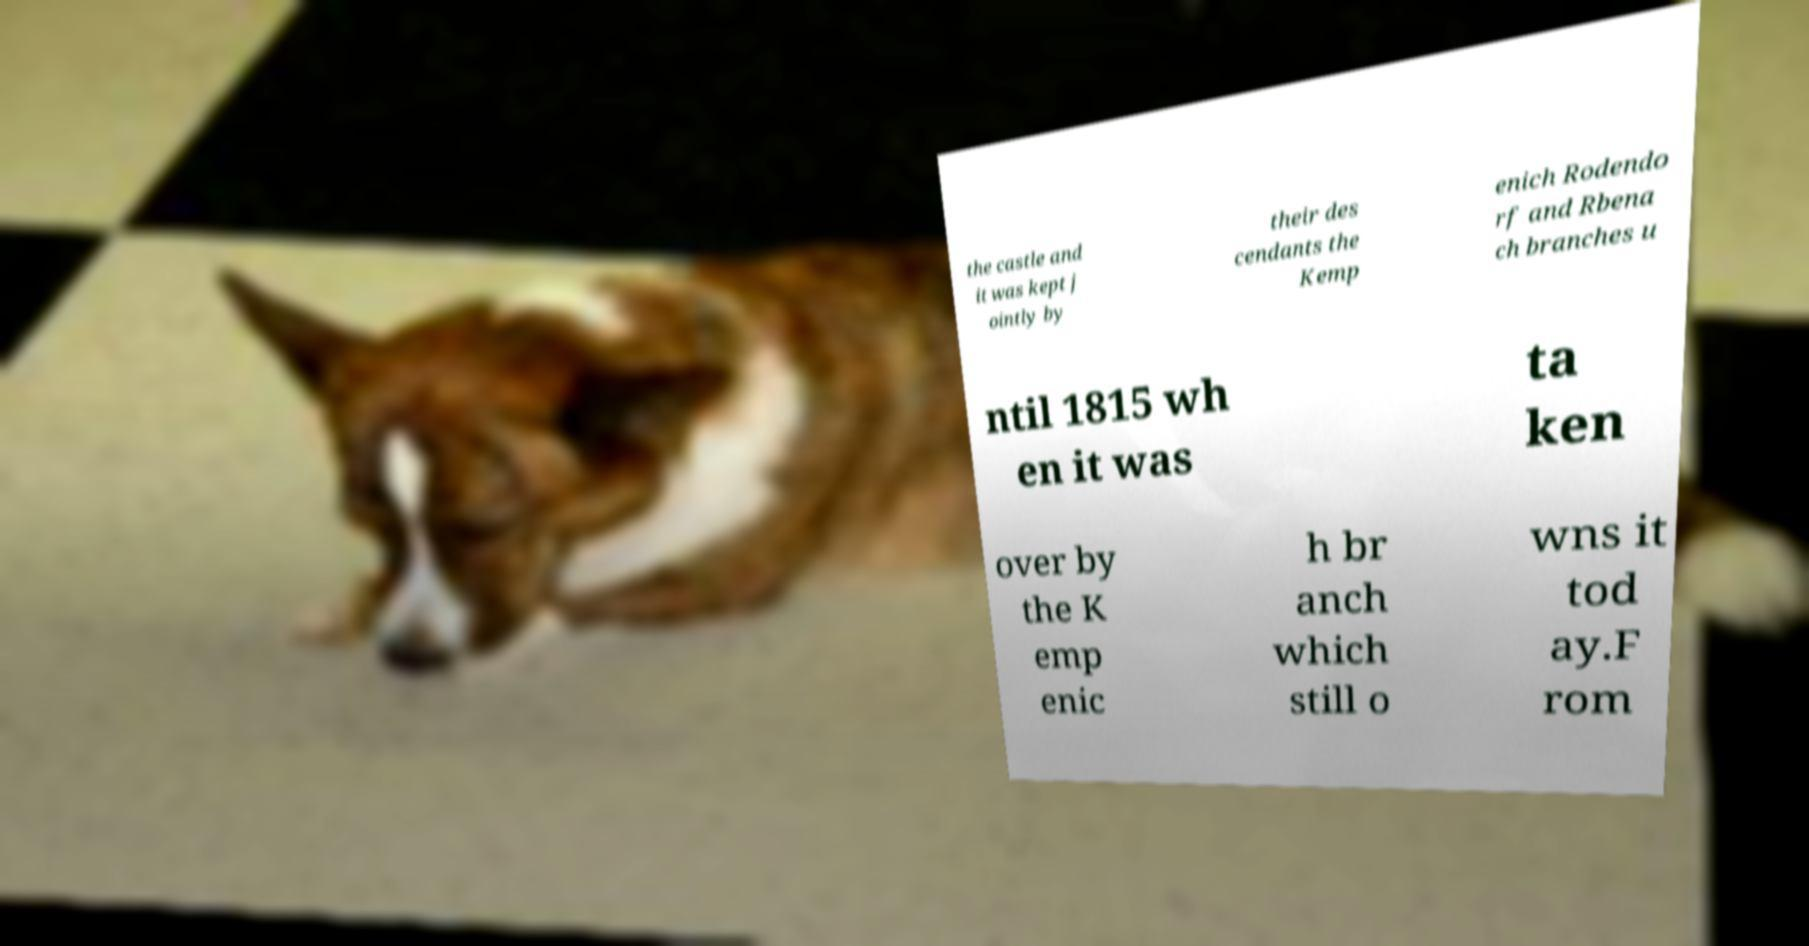There's text embedded in this image that I need extracted. Can you transcribe it verbatim? the castle and it was kept j ointly by their des cendants the Kemp enich Rodendo rf and Rbena ch branches u ntil 1815 wh en it was ta ken over by the K emp enic h br anch which still o wns it tod ay.F rom 